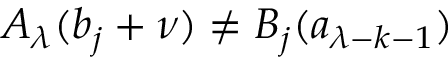<formula> <loc_0><loc_0><loc_500><loc_500>A _ { \lambda } ( b _ { j } + \nu ) \neq B _ { j } ( a _ { \lambda - k - 1 } )</formula> 